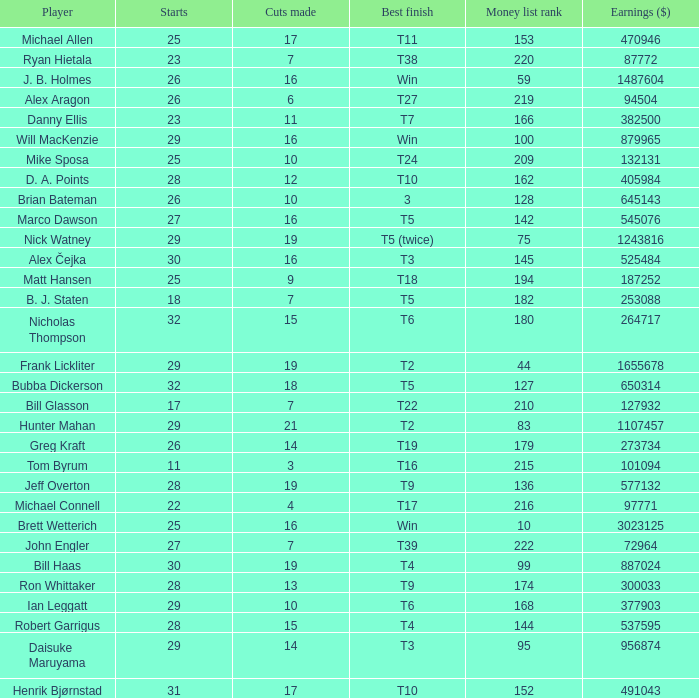What is the minimum number of cuts made for Hunter Mahan? 21.0. 